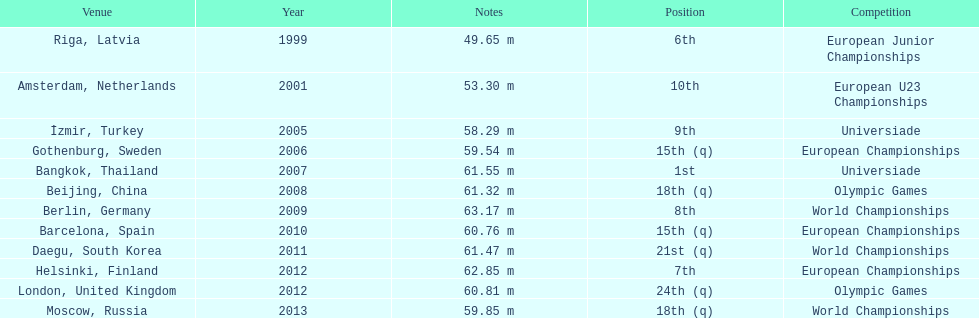What was mayer's best result: i.e his longest throw? 63.17 m. 